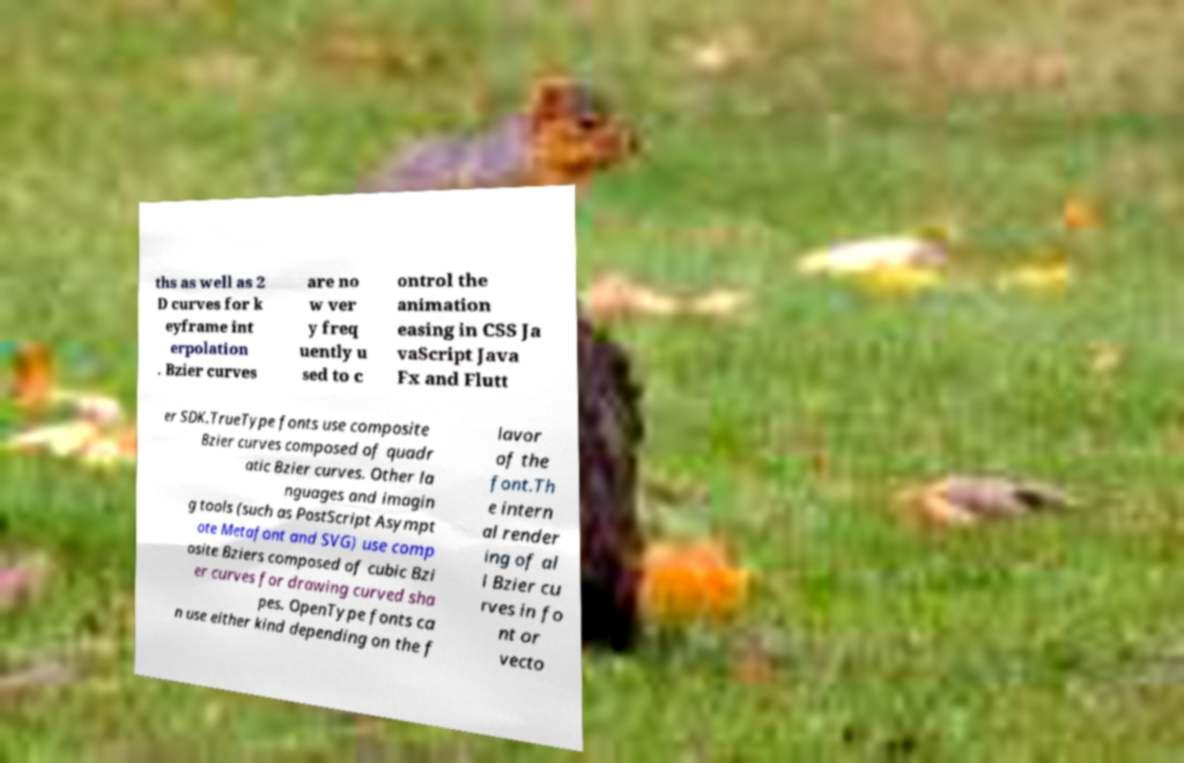Please read and relay the text visible in this image. What does it say? ths as well as 2 D curves for k eyframe int erpolation . Bzier curves are no w ver y freq uently u sed to c ontrol the animation easing in CSS Ja vaScript Java Fx and Flutt er SDK.TrueType fonts use composite Bzier curves composed of quadr atic Bzier curves. Other la nguages and imagin g tools (such as PostScript Asympt ote Metafont and SVG) use comp osite Bziers composed of cubic Bzi er curves for drawing curved sha pes. OpenType fonts ca n use either kind depending on the f lavor of the font.Th e intern al render ing of al l Bzier cu rves in fo nt or vecto 